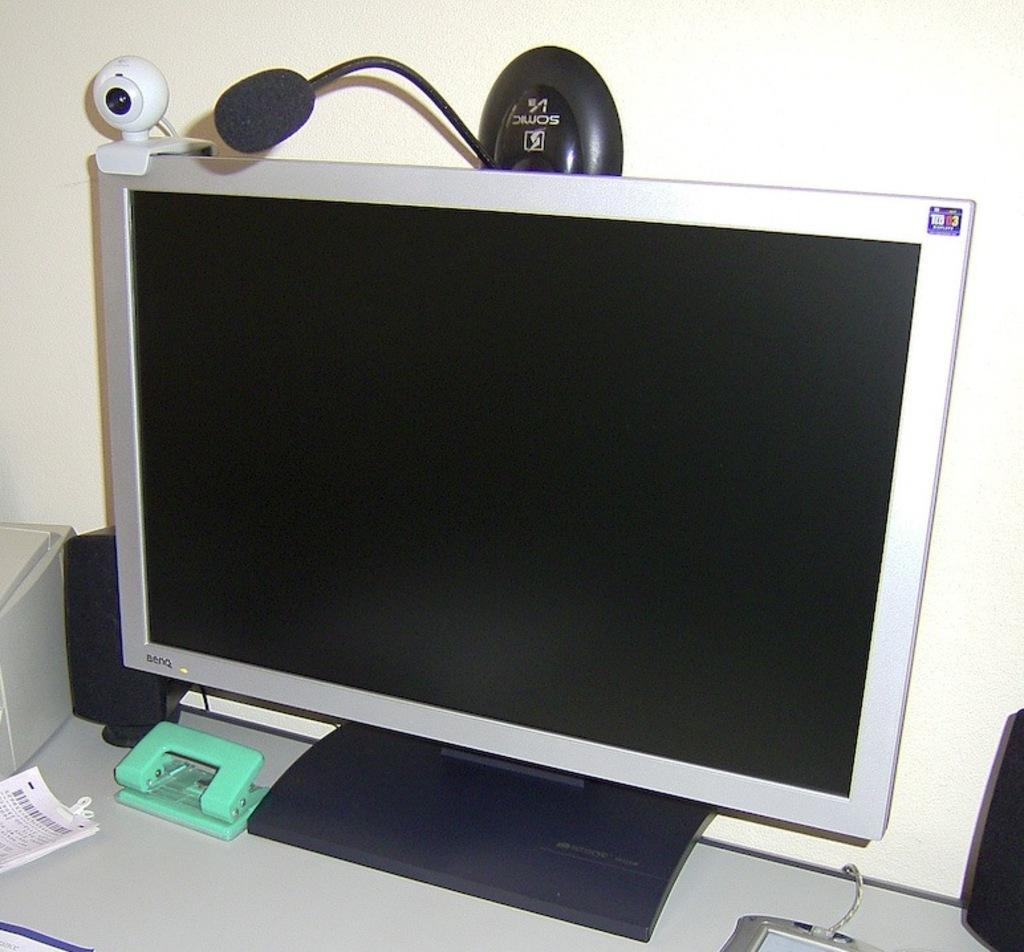Provide a one-sentence caption for the provided image. A sticker in the upper right corner of a monitor screen says "03". 